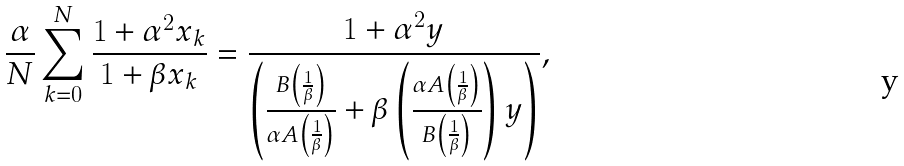<formula> <loc_0><loc_0><loc_500><loc_500>\frac { \alpha } { N } \sum _ { k = 0 } ^ { N } \frac { 1 + \alpha ^ { 2 } x _ { k } } { 1 + \beta x _ { k } } = \frac { 1 + \alpha ^ { 2 } y } { \left ( \frac { B \left ( \frac { 1 } { \beta } \right ) } { \alpha A \left ( \frac { 1 } { \beta } \right ) } + \beta \left ( \frac { \alpha A \left ( \frac { 1 } { \beta } \right ) } { B \left ( \frac { 1 } { \beta } \right ) } \right ) y \right ) } ,</formula> 